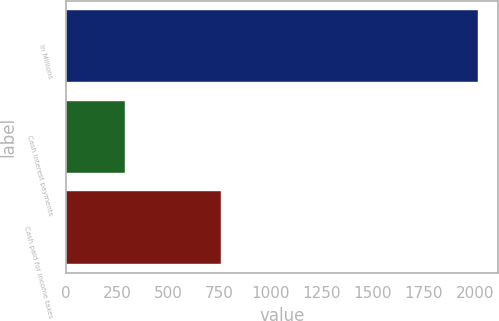Convert chart to OTSL. <chart><loc_0><loc_0><loc_500><loc_500><bar_chart><fcel>In Millions<fcel>Cash interest payments<fcel>Cash paid for income taxes<nl><fcel>2014<fcel>288.3<fcel>757.2<nl></chart> 